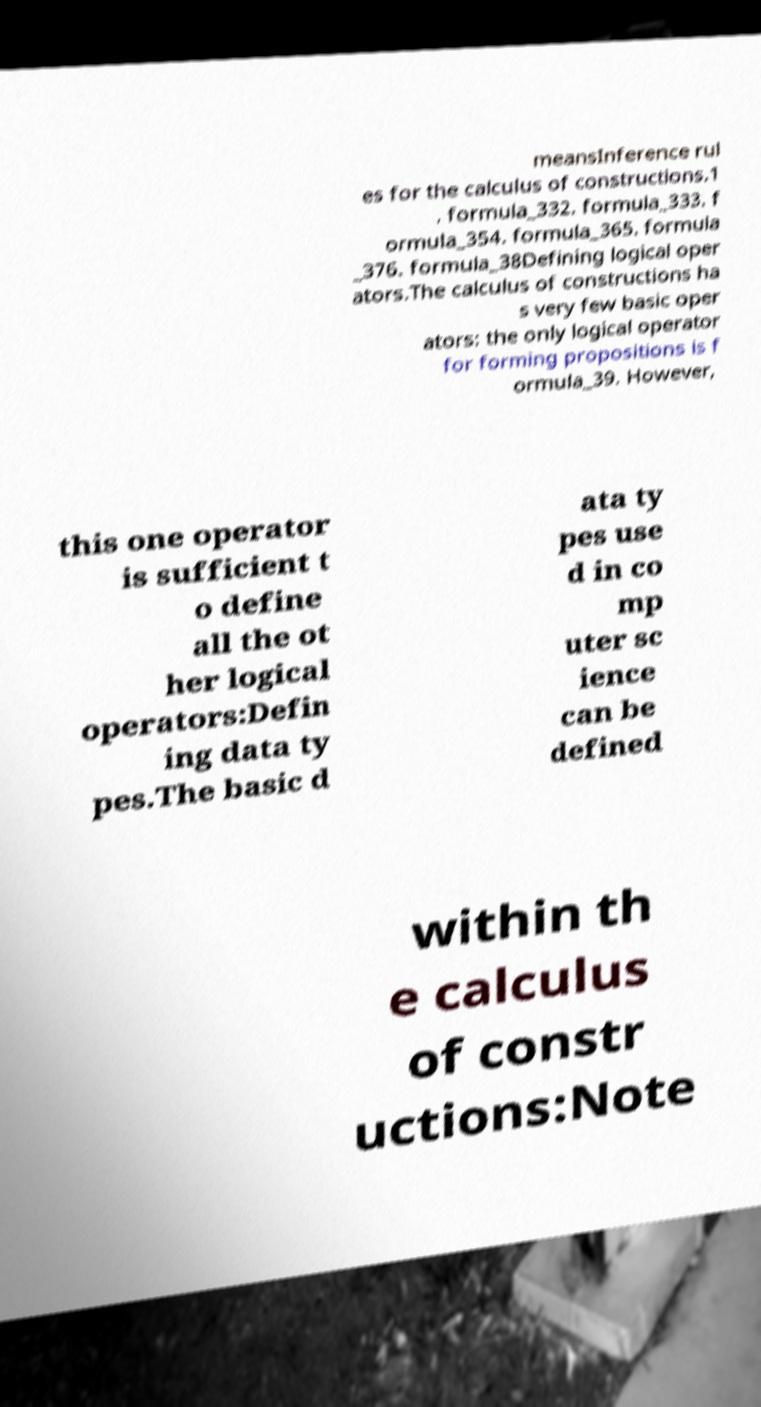Please read and relay the text visible in this image. What does it say? meansInference rul es for the calculus of constructions.1 . formula_332. formula_333. f ormula_354. formula_365. formula _376. formula_38Defining logical oper ators.The calculus of constructions ha s very few basic oper ators: the only logical operator for forming propositions is f ormula_39. However, this one operator is sufficient t o define all the ot her logical operators:Defin ing data ty pes.The basic d ata ty pes use d in co mp uter sc ience can be defined within th e calculus of constr uctions:Note 